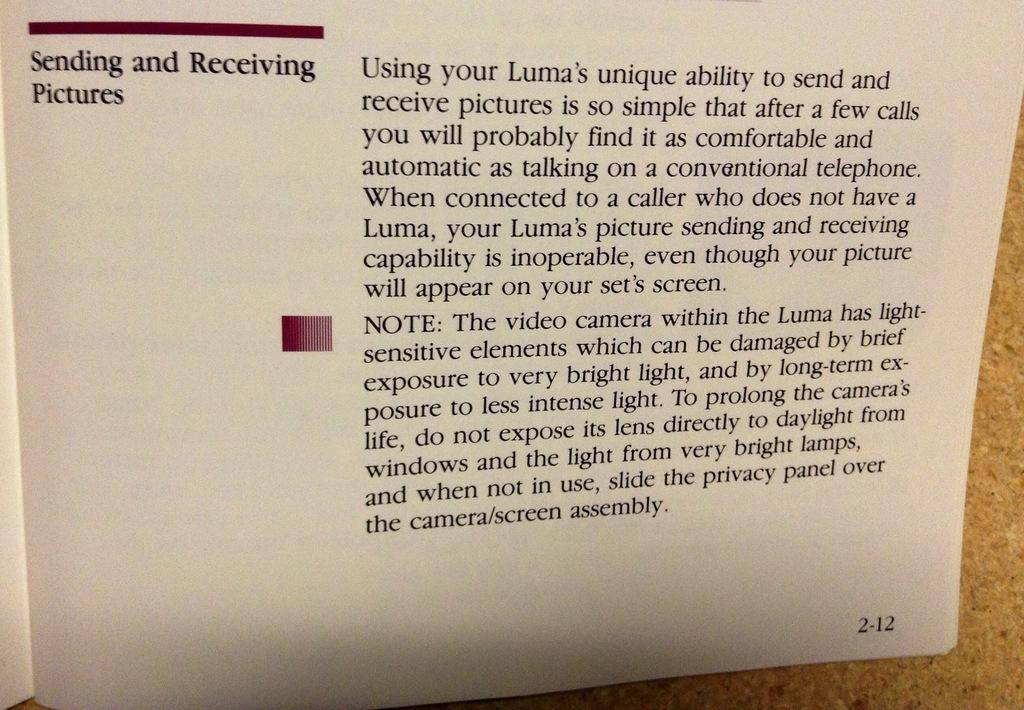<image>
Present a compact description of the photo's key features. Turn to the instructions on page 2-12 to find information on sending and receiving pictures. 